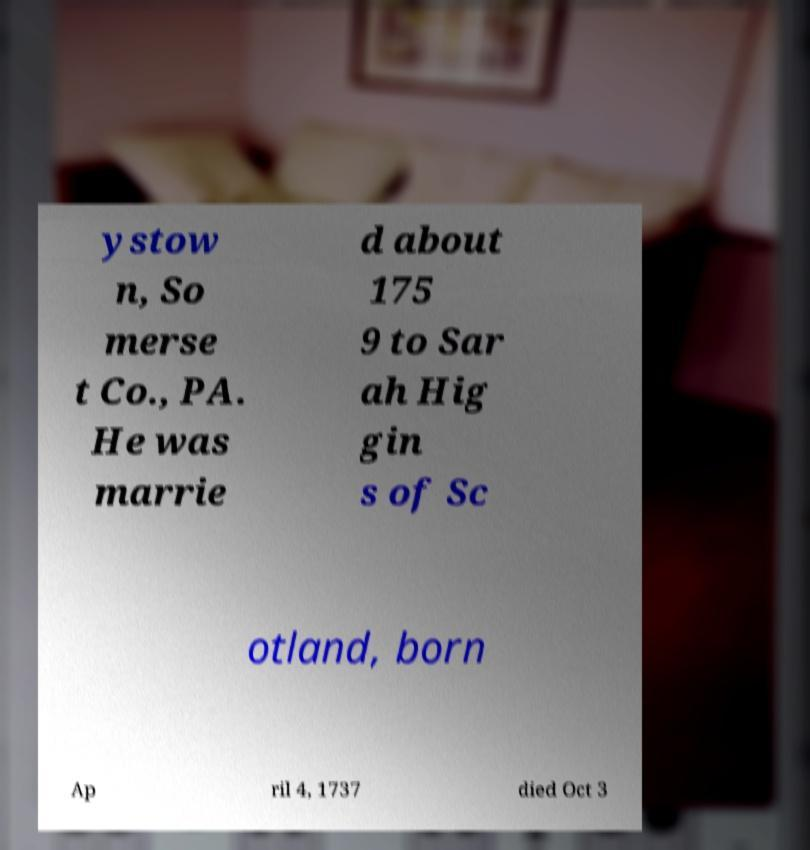Please identify and transcribe the text found in this image. ystow n, So merse t Co., PA. He was marrie d about 175 9 to Sar ah Hig gin s of Sc otland, born Ap ril 4, 1737 died Oct 3 